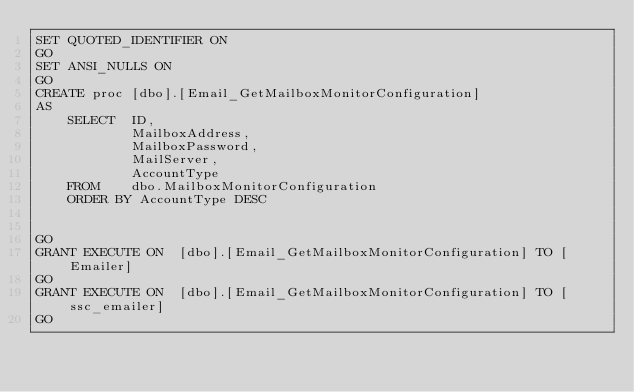Convert code to text. <code><loc_0><loc_0><loc_500><loc_500><_SQL_>SET QUOTED_IDENTIFIER ON
GO
SET ANSI_NULLS ON
GO
CREATE proc [dbo].[Email_GetMailboxMonitorConfiguration]
AS  
    SELECT  ID,
            MailboxAddress,
            MailboxPassword,
            MailServer,
            AccountType
    FROM    dbo.MailboxMonitorConfiguration
    ORDER BY AccountType DESC 


GO
GRANT EXECUTE ON  [dbo].[Email_GetMailboxMonitorConfiguration] TO [Emailer]
GO
GRANT EXECUTE ON  [dbo].[Email_GetMailboxMonitorConfiguration] TO [ssc_emailer]
GO
</code> 